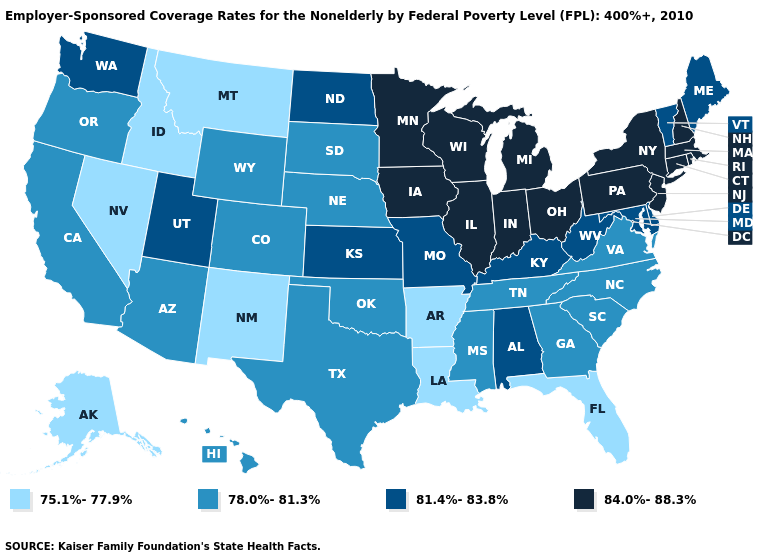Does the first symbol in the legend represent the smallest category?
Write a very short answer. Yes. Which states have the highest value in the USA?
Concise answer only. Connecticut, Illinois, Indiana, Iowa, Massachusetts, Michigan, Minnesota, New Hampshire, New Jersey, New York, Ohio, Pennsylvania, Rhode Island, Wisconsin. Does Maine have a lower value than Oregon?
Give a very brief answer. No. How many symbols are there in the legend?
Answer briefly. 4. Name the states that have a value in the range 78.0%-81.3%?
Quick response, please. Arizona, California, Colorado, Georgia, Hawaii, Mississippi, Nebraska, North Carolina, Oklahoma, Oregon, South Carolina, South Dakota, Tennessee, Texas, Virginia, Wyoming. Name the states that have a value in the range 84.0%-88.3%?
Quick response, please. Connecticut, Illinois, Indiana, Iowa, Massachusetts, Michigan, Minnesota, New Hampshire, New Jersey, New York, Ohio, Pennsylvania, Rhode Island, Wisconsin. What is the value of Delaware?
Answer briefly. 81.4%-83.8%. Does Colorado have a lower value than Connecticut?
Short answer required. Yes. What is the highest value in states that border Florida?
Keep it brief. 81.4%-83.8%. Does New York have the highest value in the Northeast?
Keep it brief. Yes. Among the states that border Arkansas , which have the highest value?
Keep it brief. Missouri. What is the value of Maine?
Answer briefly. 81.4%-83.8%. What is the value of Mississippi?
Quick response, please. 78.0%-81.3%. Among the states that border Connecticut , which have the highest value?
Be succinct. Massachusetts, New York, Rhode Island. Does Michigan have the lowest value in the MidWest?
Keep it brief. No. 